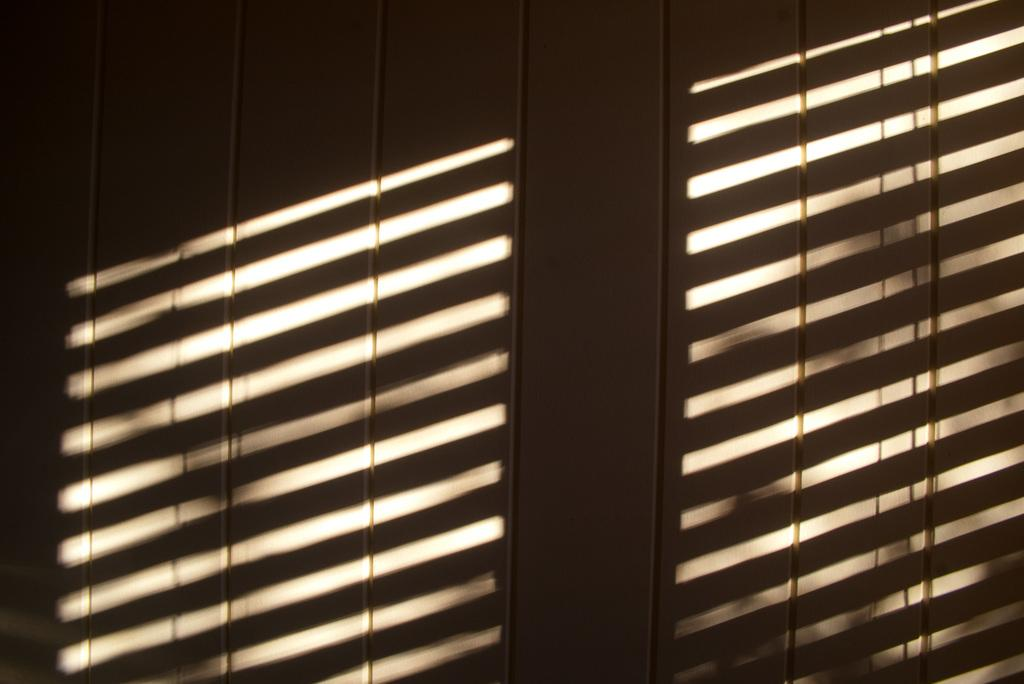What can be observed on the wall in the image? There are shadows on the wall in the image. What type of cattle can be seen interacting with the drawer in the image? There is no cattle or drawer present in the image; it only features shadows on the wall. What color is the chalk used to draw the shadows in the image? The image does not show the process of drawing the shadows, so it is impossible to determine the color of any chalk used. 